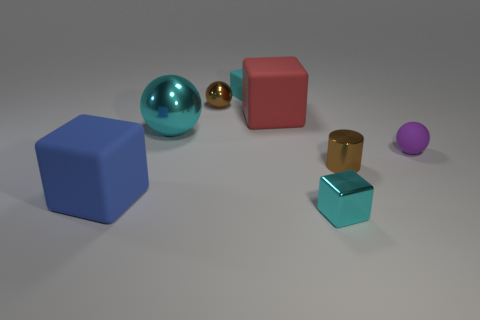Subtract all small spheres. How many spheres are left? 1 Add 2 cyan balls. How many objects exist? 10 Subtract 4 cubes. How many cubes are left? 0 Add 8 large red matte cubes. How many large red matte cubes are left? 9 Add 2 purple matte objects. How many purple matte objects exist? 3 Subtract all brown spheres. How many spheres are left? 2 Subtract 0 yellow balls. How many objects are left? 8 Subtract all cylinders. How many objects are left? 7 Subtract all purple cylinders. Subtract all brown cubes. How many cylinders are left? 1 Subtract all red cubes. How many red spheres are left? 0 